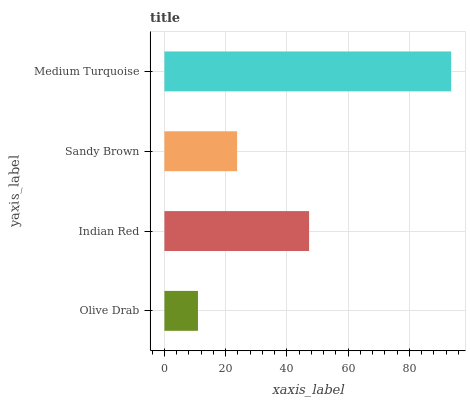Is Olive Drab the minimum?
Answer yes or no. Yes. Is Medium Turquoise the maximum?
Answer yes or no. Yes. Is Indian Red the minimum?
Answer yes or no. No. Is Indian Red the maximum?
Answer yes or no. No. Is Indian Red greater than Olive Drab?
Answer yes or no. Yes. Is Olive Drab less than Indian Red?
Answer yes or no. Yes. Is Olive Drab greater than Indian Red?
Answer yes or no. No. Is Indian Red less than Olive Drab?
Answer yes or no. No. Is Indian Red the high median?
Answer yes or no. Yes. Is Sandy Brown the low median?
Answer yes or no. Yes. Is Olive Drab the high median?
Answer yes or no. No. Is Indian Red the low median?
Answer yes or no. No. 